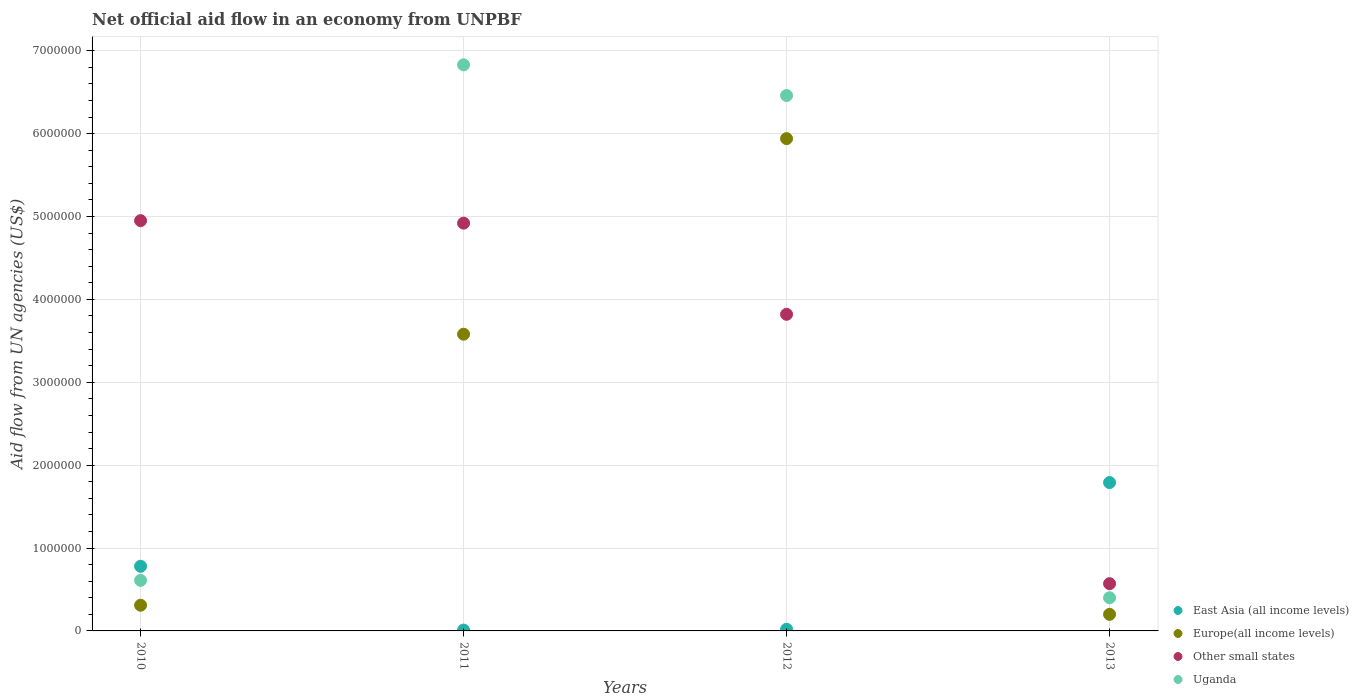Is the number of dotlines equal to the number of legend labels?
Give a very brief answer. Yes. What is the net official aid flow in Other small states in 2012?
Give a very brief answer. 3.82e+06. Across all years, what is the maximum net official aid flow in East Asia (all income levels)?
Make the answer very short. 1.79e+06. Across all years, what is the minimum net official aid flow in East Asia (all income levels)?
Offer a very short reply. 10000. In which year was the net official aid flow in Europe(all income levels) minimum?
Your response must be concise. 2013. What is the total net official aid flow in Other small states in the graph?
Make the answer very short. 1.43e+07. What is the difference between the net official aid flow in Uganda in 2010 and that in 2013?
Your answer should be very brief. 2.10e+05. What is the difference between the net official aid flow in Other small states in 2011 and the net official aid flow in Uganda in 2012?
Provide a short and direct response. -1.54e+06. What is the average net official aid flow in Europe(all income levels) per year?
Provide a succinct answer. 2.51e+06. In the year 2010, what is the difference between the net official aid flow in East Asia (all income levels) and net official aid flow in Europe(all income levels)?
Ensure brevity in your answer.  4.70e+05. What is the ratio of the net official aid flow in Europe(all income levels) in 2010 to that in 2013?
Ensure brevity in your answer.  1.55. Is the net official aid flow in Other small states in 2010 less than that in 2011?
Ensure brevity in your answer.  No. What is the difference between the highest and the second highest net official aid flow in Uganda?
Ensure brevity in your answer.  3.70e+05. What is the difference between the highest and the lowest net official aid flow in Europe(all income levels)?
Provide a succinct answer. 5.74e+06. Is it the case that in every year, the sum of the net official aid flow in Uganda and net official aid flow in Other small states  is greater than the sum of net official aid flow in Europe(all income levels) and net official aid flow in East Asia (all income levels)?
Offer a terse response. Yes. How many dotlines are there?
Make the answer very short. 4. How many years are there in the graph?
Ensure brevity in your answer.  4. Are the values on the major ticks of Y-axis written in scientific E-notation?
Make the answer very short. No. Does the graph contain any zero values?
Provide a short and direct response. No. Where does the legend appear in the graph?
Your response must be concise. Bottom right. How many legend labels are there?
Ensure brevity in your answer.  4. How are the legend labels stacked?
Ensure brevity in your answer.  Vertical. What is the title of the graph?
Ensure brevity in your answer.  Net official aid flow in an economy from UNPBF. What is the label or title of the X-axis?
Make the answer very short. Years. What is the label or title of the Y-axis?
Give a very brief answer. Aid flow from UN agencies (US$). What is the Aid flow from UN agencies (US$) of East Asia (all income levels) in 2010?
Ensure brevity in your answer.  7.80e+05. What is the Aid flow from UN agencies (US$) of Other small states in 2010?
Your answer should be very brief. 4.95e+06. What is the Aid flow from UN agencies (US$) of Uganda in 2010?
Ensure brevity in your answer.  6.10e+05. What is the Aid flow from UN agencies (US$) in Europe(all income levels) in 2011?
Keep it short and to the point. 3.58e+06. What is the Aid flow from UN agencies (US$) of Other small states in 2011?
Keep it short and to the point. 4.92e+06. What is the Aid flow from UN agencies (US$) in Uganda in 2011?
Ensure brevity in your answer.  6.83e+06. What is the Aid flow from UN agencies (US$) of Europe(all income levels) in 2012?
Offer a very short reply. 5.94e+06. What is the Aid flow from UN agencies (US$) in Other small states in 2012?
Make the answer very short. 3.82e+06. What is the Aid flow from UN agencies (US$) of Uganda in 2012?
Offer a terse response. 6.46e+06. What is the Aid flow from UN agencies (US$) in East Asia (all income levels) in 2013?
Provide a short and direct response. 1.79e+06. What is the Aid flow from UN agencies (US$) in Europe(all income levels) in 2013?
Give a very brief answer. 2.00e+05. What is the Aid flow from UN agencies (US$) of Other small states in 2013?
Offer a terse response. 5.70e+05. Across all years, what is the maximum Aid flow from UN agencies (US$) of East Asia (all income levels)?
Keep it short and to the point. 1.79e+06. Across all years, what is the maximum Aid flow from UN agencies (US$) of Europe(all income levels)?
Offer a terse response. 5.94e+06. Across all years, what is the maximum Aid flow from UN agencies (US$) in Other small states?
Ensure brevity in your answer.  4.95e+06. Across all years, what is the maximum Aid flow from UN agencies (US$) of Uganda?
Provide a succinct answer. 6.83e+06. Across all years, what is the minimum Aid flow from UN agencies (US$) of Europe(all income levels)?
Provide a succinct answer. 2.00e+05. Across all years, what is the minimum Aid flow from UN agencies (US$) of Other small states?
Make the answer very short. 5.70e+05. What is the total Aid flow from UN agencies (US$) of East Asia (all income levels) in the graph?
Ensure brevity in your answer.  2.60e+06. What is the total Aid flow from UN agencies (US$) of Europe(all income levels) in the graph?
Give a very brief answer. 1.00e+07. What is the total Aid flow from UN agencies (US$) of Other small states in the graph?
Your response must be concise. 1.43e+07. What is the total Aid flow from UN agencies (US$) of Uganda in the graph?
Provide a short and direct response. 1.43e+07. What is the difference between the Aid flow from UN agencies (US$) of East Asia (all income levels) in 2010 and that in 2011?
Your answer should be compact. 7.70e+05. What is the difference between the Aid flow from UN agencies (US$) in Europe(all income levels) in 2010 and that in 2011?
Your response must be concise. -3.27e+06. What is the difference between the Aid flow from UN agencies (US$) in Uganda in 2010 and that in 2011?
Your response must be concise. -6.22e+06. What is the difference between the Aid flow from UN agencies (US$) in East Asia (all income levels) in 2010 and that in 2012?
Your answer should be compact. 7.60e+05. What is the difference between the Aid flow from UN agencies (US$) in Europe(all income levels) in 2010 and that in 2012?
Your answer should be very brief. -5.63e+06. What is the difference between the Aid flow from UN agencies (US$) in Other small states in 2010 and that in 2012?
Ensure brevity in your answer.  1.13e+06. What is the difference between the Aid flow from UN agencies (US$) of Uganda in 2010 and that in 2012?
Your answer should be compact. -5.85e+06. What is the difference between the Aid flow from UN agencies (US$) of East Asia (all income levels) in 2010 and that in 2013?
Your answer should be compact. -1.01e+06. What is the difference between the Aid flow from UN agencies (US$) in Other small states in 2010 and that in 2013?
Make the answer very short. 4.38e+06. What is the difference between the Aid flow from UN agencies (US$) in East Asia (all income levels) in 2011 and that in 2012?
Your answer should be compact. -10000. What is the difference between the Aid flow from UN agencies (US$) in Europe(all income levels) in 2011 and that in 2012?
Provide a succinct answer. -2.36e+06. What is the difference between the Aid flow from UN agencies (US$) of Other small states in 2011 and that in 2012?
Your answer should be very brief. 1.10e+06. What is the difference between the Aid flow from UN agencies (US$) of East Asia (all income levels) in 2011 and that in 2013?
Offer a terse response. -1.78e+06. What is the difference between the Aid flow from UN agencies (US$) in Europe(all income levels) in 2011 and that in 2013?
Give a very brief answer. 3.38e+06. What is the difference between the Aid flow from UN agencies (US$) of Other small states in 2011 and that in 2013?
Your answer should be compact. 4.35e+06. What is the difference between the Aid flow from UN agencies (US$) of Uganda in 2011 and that in 2013?
Your answer should be compact. 6.43e+06. What is the difference between the Aid flow from UN agencies (US$) of East Asia (all income levels) in 2012 and that in 2013?
Make the answer very short. -1.77e+06. What is the difference between the Aid flow from UN agencies (US$) in Europe(all income levels) in 2012 and that in 2013?
Your answer should be compact. 5.74e+06. What is the difference between the Aid flow from UN agencies (US$) in Other small states in 2012 and that in 2013?
Give a very brief answer. 3.25e+06. What is the difference between the Aid flow from UN agencies (US$) in Uganda in 2012 and that in 2013?
Offer a very short reply. 6.06e+06. What is the difference between the Aid flow from UN agencies (US$) in East Asia (all income levels) in 2010 and the Aid flow from UN agencies (US$) in Europe(all income levels) in 2011?
Provide a succinct answer. -2.80e+06. What is the difference between the Aid flow from UN agencies (US$) of East Asia (all income levels) in 2010 and the Aid flow from UN agencies (US$) of Other small states in 2011?
Offer a very short reply. -4.14e+06. What is the difference between the Aid flow from UN agencies (US$) of East Asia (all income levels) in 2010 and the Aid flow from UN agencies (US$) of Uganda in 2011?
Give a very brief answer. -6.05e+06. What is the difference between the Aid flow from UN agencies (US$) of Europe(all income levels) in 2010 and the Aid flow from UN agencies (US$) of Other small states in 2011?
Keep it short and to the point. -4.61e+06. What is the difference between the Aid flow from UN agencies (US$) of Europe(all income levels) in 2010 and the Aid flow from UN agencies (US$) of Uganda in 2011?
Give a very brief answer. -6.52e+06. What is the difference between the Aid flow from UN agencies (US$) of Other small states in 2010 and the Aid flow from UN agencies (US$) of Uganda in 2011?
Your response must be concise. -1.88e+06. What is the difference between the Aid flow from UN agencies (US$) of East Asia (all income levels) in 2010 and the Aid flow from UN agencies (US$) of Europe(all income levels) in 2012?
Your answer should be compact. -5.16e+06. What is the difference between the Aid flow from UN agencies (US$) in East Asia (all income levels) in 2010 and the Aid flow from UN agencies (US$) in Other small states in 2012?
Offer a very short reply. -3.04e+06. What is the difference between the Aid flow from UN agencies (US$) in East Asia (all income levels) in 2010 and the Aid flow from UN agencies (US$) in Uganda in 2012?
Ensure brevity in your answer.  -5.68e+06. What is the difference between the Aid flow from UN agencies (US$) of Europe(all income levels) in 2010 and the Aid flow from UN agencies (US$) of Other small states in 2012?
Give a very brief answer. -3.51e+06. What is the difference between the Aid flow from UN agencies (US$) in Europe(all income levels) in 2010 and the Aid flow from UN agencies (US$) in Uganda in 2012?
Your response must be concise. -6.15e+06. What is the difference between the Aid flow from UN agencies (US$) of Other small states in 2010 and the Aid flow from UN agencies (US$) of Uganda in 2012?
Offer a very short reply. -1.51e+06. What is the difference between the Aid flow from UN agencies (US$) of East Asia (all income levels) in 2010 and the Aid flow from UN agencies (US$) of Europe(all income levels) in 2013?
Your answer should be very brief. 5.80e+05. What is the difference between the Aid flow from UN agencies (US$) of East Asia (all income levels) in 2010 and the Aid flow from UN agencies (US$) of Uganda in 2013?
Your answer should be very brief. 3.80e+05. What is the difference between the Aid flow from UN agencies (US$) of Other small states in 2010 and the Aid flow from UN agencies (US$) of Uganda in 2013?
Give a very brief answer. 4.55e+06. What is the difference between the Aid flow from UN agencies (US$) in East Asia (all income levels) in 2011 and the Aid flow from UN agencies (US$) in Europe(all income levels) in 2012?
Your answer should be compact. -5.93e+06. What is the difference between the Aid flow from UN agencies (US$) in East Asia (all income levels) in 2011 and the Aid flow from UN agencies (US$) in Other small states in 2012?
Provide a succinct answer. -3.81e+06. What is the difference between the Aid flow from UN agencies (US$) of East Asia (all income levels) in 2011 and the Aid flow from UN agencies (US$) of Uganda in 2012?
Give a very brief answer. -6.45e+06. What is the difference between the Aid flow from UN agencies (US$) in Europe(all income levels) in 2011 and the Aid flow from UN agencies (US$) in Uganda in 2012?
Your response must be concise. -2.88e+06. What is the difference between the Aid flow from UN agencies (US$) of Other small states in 2011 and the Aid flow from UN agencies (US$) of Uganda in 2012?
Keep it short and to the point. -1.54e+06. What is the difference between the Aid flow from UN agencies (US$) in East Asia (all income levels) in 2011 and the Aid flow from UN agencies (US$) in Europe(all income levels) in 2013?
Make the answer very short. -1.90e+05. What is the difference between the Aid flow from UN agencies (US$) of East Asia (all income levels) in 2011 and the Aid flow from UN agencies (US$) of Other small states in 2013?
Offer a very short reply. -5.60e+05. What is the difference between the Aid flow from UN agencies (US$) of East Asia (all income levels) in 2011 and the Aid flow from UN agencies (US$) of Uganda in 2013?
Your response must be concise. -3.90e+05. What is the difference between the Aid flow from UN agencies (US$) of Europe(all income levels) in 2011 and the Aid flow from UN agencies (US$) of Other small states in 2013?
Make the answer very short. 3.01e+06. What is the difference between the Aid flow from UN agencies (US$) of Europe(all income levels) in 2011 and the Aid flow from UN agencies (US$) of Uganda in 2013?
Your answer should be very brief. 3.18e+06. What is the difference between the Aid flow from UN agencies (US$) of Other small states in 2011 and the Aid flow from UN agencies (US$) of Uganda in 2013?
Your answer should be compact. 4.52e+06. What is the difference between the Aid flow from UN agencies (US$) in East Asia (all income levels) in 2012 and the Aid flow from UN agencies (US$) in Europe(all income levels) in 2013?
Keep it short and to the point. -1.80e+05. What is the difference between the Aid flow from UN agencies (US$) in East Asia (all income levels) in 2012 and the Aid flow from UN agencies (US$) in Other small states in 2013?
Your response must be concise. -5.50e+05. What is the difference between the Aid flow from UN agencies (US$) of East Asia (all income levels) in 2012 and the Aid flow from UN agencies (US$) of Uganda in 2013?
Your response must be concise. -3.80e+05. What is the difference between the Aid flow from UN agencies (US$) in Europe(all income levels) in 2012 and the Aid flow from UN agencies (US$) in Other small states in 2013?
Offer a very short reply. 5.37e+06. What is the difference between the Aid flow from UN agencies (US$) in Europe(all income levels) in 2012 and the Aid flow from UN agencies (US$) in Uganda in 2013?
Give a very brief answer. 5.54e+06. What is the difference between the Aid flow from UN agencies (US$) of Other small states in 2012 and the Aid flow from UN agencies (US$) of Uganda in 2013?
Make the answer very short. 3.42e+06. What is the average Aid flow from UN agencies (US$) of East Asia (all income levels) per year?
Keep it short and to the point. 6.50e+05. What is the average Aid flow from UN agencies (US$) of Europe(all income levels) per year?
Give a very brief answer. 2.51e+06. What is the average Aid flow from UN agencies (US$) of Other small states per year?
Keep it short and to the point. 3.56e+06. What is the average Aid flow from UN agencies (US$) of Uganda per year?
Provide a short and direct response. 3.58e+06. In the year 2010, what is the difference between the Aid flow from UN agencies (US$) in East Asia (all income levels) and Aid flow from UN agencies (US$) in Europe(all income levels)?
Keep it short and to the point. 4.70e+05. In the year 2010, what is the difference between the Aid flow from UN agencies (US$) of East Asia (all income levels) and Aid flow from UN agencies (US$) of Other small states?
Offer a very short reply. -4.17e+06. In the year 2010, what is the difference between the Aid flow from UN agencies (US$) in Europe(all income levels) and Aid flow from UN agencies (US$) in Other small states?
Provide a short and direct response. -4.64e+06. In the year 2010, what is the difference between the Aid flow from UN agencies (US$) of Other small states and Aid flow from UN agencies (US$) of Uganda?
Make the answer very short. 4.34e+06. In the year 2011, what is the difference between the Aid flow from UN agencies (US$) of East Asia (all income levels) and Aid flow from UN agencies (US$) of Europe(all income levels)?
Give a very brief answer. -3.57e+06. In the year 2011, what is the difference between the Aid flow from UN agencies (US$) in East Asia (all income levels) and Aid flow from UN agencies (US$) in Other small states?
Offer a terse response. -4.91e+06. In the year 2011, what is the difference between the Aid flow from UN agencies (US$) of East Asia (all income levels) and Aid flow from UN agencies (US$) of Uganda?
Provide a succinct answer. -6.82e+06. In the year 2011, what is the difference between the Aid flow from UN agencies (US$) of Europe(all income levels) and Aid flow from UN agencies (US$) of Other small states?
Make the answer very short. -1.34e+06. In the year 2011, what is the difference between the Aid flow from UN agencies (US$) of Europe(all income levels) and Aid flow from UN agencies (US$) of Uganda?
Provide a succinct answer. -3.25e+06. In the year 2011, what is the difference between the Aid flow from UN agencies (US$) in Other small states and Aid flow from UN agencies (US$) in Uganda?
Ensure brevity in your answer.  -1.91e+06. In the year 2012, what is the difference between the Aid flow from UN agencies (US$) of East Asia (all income levels) and Aid flow from UN agencies (US$) of Europe(all income levels)?
Your response must be concise. -5.92e+06. In the year 2012, what is the difference between the Aid flow from UN agencies (US$) in East Asia (all income levels) and Aid flow from UN agencies (US$) in Other small states?
Give a very brief answer. -3.80e+06. In the year 2012, what is the difference between the Aid flow from UN agencies (US$) of East Asia (all income levels) and Aid flow from UN agencies (US$) of Uganda?
Make the answer very short. -6.44e+06. In the year 2012, what is the difference between the Aid flow from UN agencies (US$) in Europe(all income levels) and Aid flow from UN agencies (US$) in Other small states?
Your answer should be very brief. 2.12e+06. In the year 2012, what is the difference between the Aid flow from UN agencies (US$) of Europe(all income levels) and Aid flow from UN agencies (US$) of Uganda?
Give a very brief answer. -5.20e+05. In the year 2012, what is the difference between the Aid flow from UN agencies (US$) in Other small states and Aid flow from UN agencies (US$) in Uganda?
Provide a succinct answer. -2.64e+06. In the year 2013, what is the difference between the Aid flow from UN agencies (US$) of East Asia (all income levels) and Aid flow from UN agencies (US$) of Europe(all income levels)?
Provide a succinct answer. 1.59e+06. In the year 2013, what is the difference between the Aid flow from UN agencies (US$) of East Asia (all income levels) and Aid flow from UN agencies (US$) of Other small states?
Make the answer very short. 1.22e+06. In the year 2013, what is the difference between the Aid flow from UN agencies (US$) of East Asia (all income levels) and Aid flow from UN agencies (US$) of Uganda?
Ensure brevity in your answer.  1.39e+06. In the year 2013, what is the difference between the Aid flow from UN agencies (US$) in Europe(all income levels) and Aid flow from UN agencies (US$) in Other small states?
Keep it short and to the point. -3.70e+05. In the year 2013, what is the difference between the Aid flow from UN agencies (US$) of Other small states and Aid flow from UN agencies (US$) of Uganda?
Provide a short and direct response. 1.70e+05. What is the ratio of the Aid flow from UN agencies (US$) of Europe(all income levels) in 2010 to that in 2011?
Ensure brevity in your answer.  0.09. What is the ratio of the Aid flow from UN agencies (US$) in Other small states in 2010 to that in 2011?
Provide a short and direct response. 1.01. What is the ratio of the Aid flow from UN agencies (US$) in Uganda in 2010 to that in 2011?
Provide a short and direct response. 0.09. What is the ratio of the Aid flow from UN agencies (US$) of Europe(all income levels) in 2010 to that in 2012?
Offer a terse response. 0.05. What is the ratio of the Aid flow from UN agencies (US$) in Other small states in 2010 to that in 2012?
Your response must be concise. 1.3. What is the ratio of the Aid flow from UN agencies (US$) in Uganda in 2010 to that in 2012?
Keep it short and to the point. 0.09. What is the ratio of the Aid flow from UN agencies (US$) in East Asia (all income levels) in 2010 to that in 2013?
Your answer should be very brief. 0.44. What is the ratio of the Aid flow from UN agencies (US$) in Europe(all income levels) in 2010 to that in 2013?
Provide a succinct answer. 1.55. What is the ratio of the Aid flow from UN agencies (US$) of Other small states in 2010 to that in 2013?
Keep it short and to the point. 8.68. What is the ratio of the Aid flow from UN agencies (US$) of Uganda in 2010 to that in 2013?
Make the answer very short. 1.52. What is the ratio of the Aid flow from UN agencies (US$) in East Asia (all income levels) in 2011 to that in 2012?
Keep it short and to the point. 0.5. What is the ratio of the Aid flow from UN agencies (US$) of Europe(all income levels) in 2011 to that in 2012?
Ensure brevity in your answer.  0.6. What is the ratio of the Aid flow from UN agencies (US$) in Other small states in 2011 to that in 2012?
Provide a short and direct response. 1.29. What is the ratio of the Aid flow from UN agencies (US$) in Uganda in 2011 to that in 2012?
Give a very brief answer. 1.06. What is the ratio of the Aid flow from UN agencies (US$) in East Asia (all income levels) in 2011 to that in 2013?
Make the answer very short. 0.01. What is the ratio of the Aid flow from UN agencies (US$) in Other small states in 2011 to that in 2013?
Ensure brevity in your answer.  8.63. What is the ratio of the Aid flow from UN agencies (US$) of Uganda in 2011 to that in 2013?
Your answer should be very brief. 17.07. What is the ratio of the Aid flow from UN agencies (US$) of East Asia (all income levels) in 2012 to that in 2013?
Offer a terse response. 0.01. What is the ratio of the Aid flow from UN agencies (US$) in Europe(all income levels) in 2012 to that in 2013?
Provide a short and direct response. 29.7. What is the ratio of the Aid flow from UN agencies (US$) in Other small states in 2012 to that in 2013?
Ensure brevity in your answer.  6.7. What is the ratio of the Aid flow from UN agencies (US$) of Uganda in 2012 to that in 2013?
Keep it short and to the point. 16.15. What is the difference between the highest and the second highest Aid flow from UN agencies (US$) in East Asia (all income levels)?
Offer a terse response. 1.01e+06. What is the difference between the highest and the second highest Aid flow from UN agencies (US$) in Europe(all income levels)?
Keep it short and to the point. 2.36e+06. What is the difference between the highest and the second highest Aid flow from UN agencies (US$) in Uganda?
Your answer should be compact. 3.70e+05. What is the difference between the highest and the lowest Aid flow from UN agencies (US$) in East Asia (all income levels)?
Make the answer very short. 1.78e+06. What is the difference between the highest and the lowest Aid flow from UN agencies (US$) of Europe(all income levels)?
Give a very brief answer. 5.74e+06. What is the difference between the highest and the lowest Aid flow from UN agencies (US$) of Other small states?
Provide a succinct answer. 4.38e+06. What is the difference between the highest and the lowest Aid flow from UN agencies (US$) of Uganda?
Offer a very short reply. 6.43e+06. 